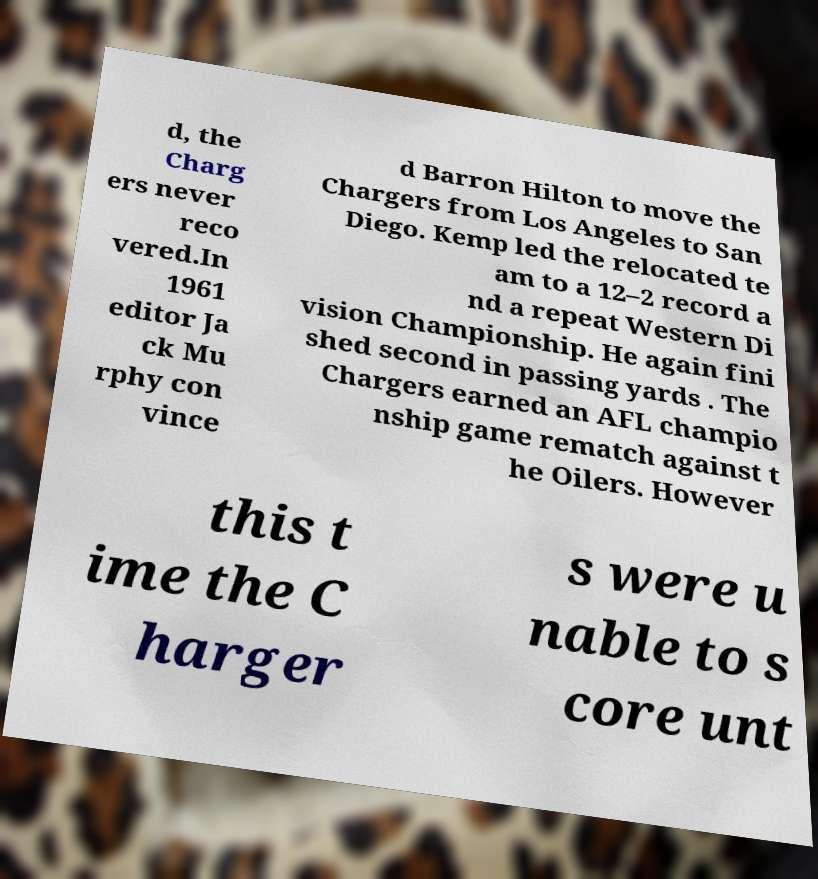Can you accurately transcribe the text from the provided image for me? d, the Charg ers never reco vered.In 1961 editor Ja ck Mu rphy con vince d Barron Hilton to move the Chargers from Los Angeles to San Diego. Kemp led the relocated te am to a 12–2 record a nd a repeat Western Di vision Championship. He again fini shed second in passing yards . The Chargers earned an AFL champio nship game rematch against t he Oilers. However this t ime the C harger s were u nable to s core unt 